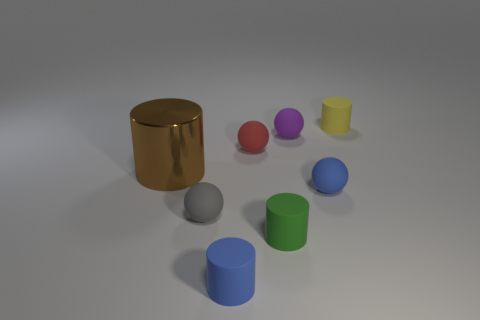Are there fewer matte cylinders right of the small purple object than tiny purple matte objects?
Offer a terse response. No. Is the shape of the yellow matte object the same as the gray thing?
Your answer should be very brief. No. What is the size of the matte cylinder behind the cylinder to the left of the blue rubber thing to the left of the tiny purple ball?
Offer a very short reply. Small. There is a blue object that is the same shape as the small yellow matte thing; what is it made of?
Ensure brevity in your answer.  Rubber. Is there any other thing that has the same size as the metal object?
Keep it short and to the point. No. There is a cylinder in front of the green rubber cylinder that is in front of the small gray thing; what is its size?
Ensure brevity in your answer.  Small. What is the color of the shiny object?
Make the answer very short. Brown. There is a tiny blue matte object left of the tiny green cylinder; what number of purple matte things are behind it?
Your response must be concise. 1. Are there any large brown cylinders that are behind the small blue matte object in front of the small blue rubber ball?
Provide a succinct answer. Yes. There is a tiny blue sphere; are there any rubber spheres right of it?
Your answer should be very brief. No. 